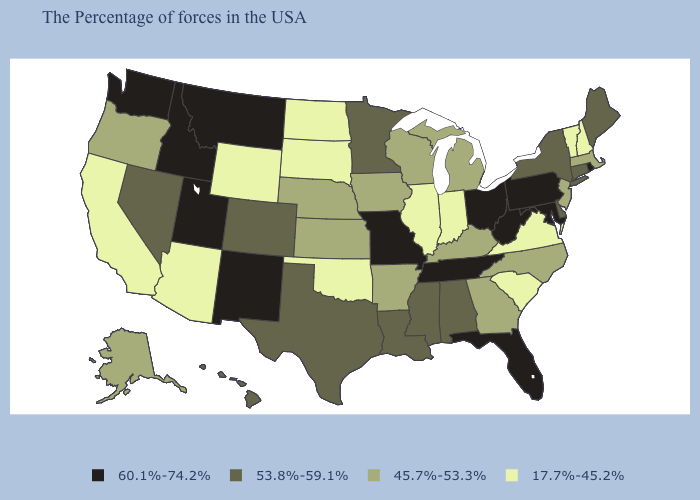Name the states that have a value in the range 60.1%-74.2%?
Be succinct. Rhode Island, Maryland, Pennsylvania, West Virginia, Ohio, Florida, Tennessee, Missouri, New Mexico, Utah, Montana, Idaho, Washington. Does Ohio have a lower value than Louisiana?
Concise answer only. No. What is the value of Missouri?
Quick response, please. 60.1%-74.2%. What is the value of Arizona?
Give a very brief answer. 17.7%-45.2%. Which states have the lowest value in the Northeast?
Concise answer only. New Hampshire, Vermont. Name the states that have a value in the range 53.8%-59.1%?
Write a very short answer. Maine, Connecticut, New York, Delaware, Alabama, Mississippi, Louisiana, Minnesota, Texas, Colorado, Nevada, Hawaii. Does New Jersey have the lowest value in the Northeast?
Short answer required. No. Name the states that have a value in the range 60.1%-74.2%?
Give a very brief answer. Rhode Island, Maryland, Pennsylvania, West Virginia, Ohio, Florida, Tennessee, Missouri, New Mexico, Utah, Montana, Idaho, Washington. What is the value of Indiana?
Keep it brief. 17.7%-45.2%. What is the lowest value in the USA?
Write a very short answer. 17.7%-45.2%. What is the value of Colorado?
Quick response, please. 53.8%-59.1%. What is the lowest value in the USA?
Write a very short answer. 17.7%-45.2%. What is the value of Michigan?
Give a very brief answer. 45.7%-53.3%. What is the value of Idaho?
Concise answer only. 60.1%-74.2%. 